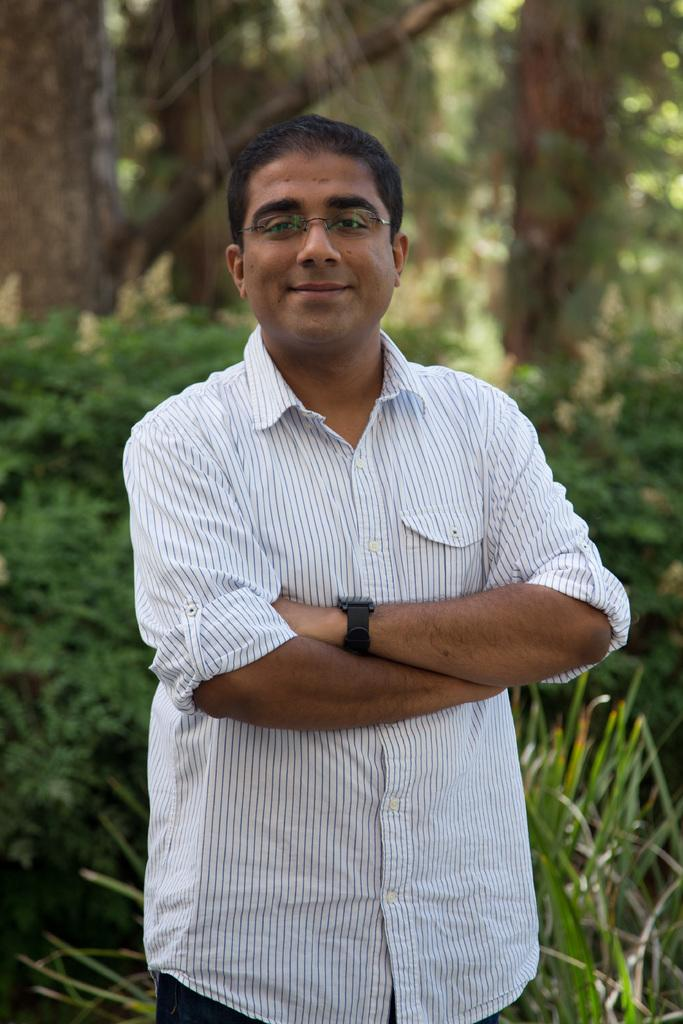Who is the main subject in the image? There is a man in the center of the image. What is the man wearing? The man is wearing glasses. What is the man doing in the image? The man is standing and smiling. What can be seen in the background of the image? There are trees, plants, and grass in the background of the image. What type of sofa is visible in the image? There is no sofa present in the image. Can you tell me how many baseballs are being held by the man in the image? There are no baseballs visible in the image; the man is not holding any. 